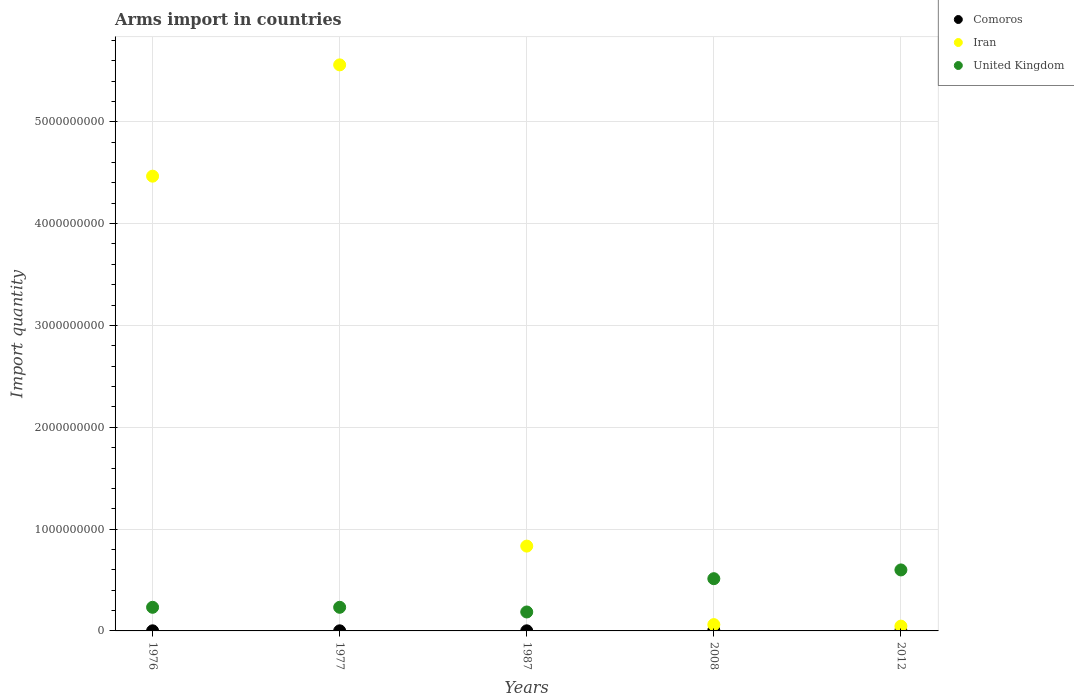Across all years, what is the maximum total arms import in Iran?
Offer a terse response. 5.56e+09. In which year was the total arms import in Comoros minimum?
Provide a short and direct response. 1976. What is the total total arms import in Iran in the graph?
Your response must be concise. 1.10e+1. What is the difference between the total arms import in Comoros in 1976 and that in 2008?
Your response must be concise. -5.00e+06. What is the difference between the total arms import in Iran in 1976 and the total arms import in Comoros in 2008?
Provide a short and direct response. 4.46e+09. What is the average total arms import in United Kingdom per year?
Ensure brevity in your answer.  3.52e+08. In the year 2012, what is the difference between the total arms import in Iran and total arms import in Comoros?
Ensure brevity in your answer.  4.60e+07. What is the difference between the highest and the second highest total arms import in Iran?
Give a very brief answer. 1.09e+09. What is the difference between the highest and the lowest total arms import in Comoros?
Ensure brevity in your answer.  5.00e+06. In how many years, is the total arms import in Iran greater than the average total arms import in Iran taken over all years?
Provide a short and direct response. 2. Is the sum of the total arms import in United Kingdom in 1976 and 1977 greater than the maximum total arms import in Comoros across all years?
Provide a succinct answer. Yes. Is it the case that in every year, the sum of the total arms import in Iran and total arms import in United Kingdom  is greater than the total arms import in Comoros?
Ensure brevity in your answer.  Yes. How many years are there in the graph?
Your response must be concise. 5. What is the difference between two consecutive major ticks on the Y-axis?
Provide a succinct answer. 1.00e+09. Are the values on the major ticks of Y-axis written in scientific E-notation?
Make the answer very short. No. Does the graph contain grids?
Give a very brief answer. Yes. How are the legend labels stacked?
Your response must be concise. Vertical. What is the title of the graph?
Provide a short and direct response. Arms import in countries. What is the label or title of the X-axis?
Your response must be concise. Years. What is the label or title of the Y-axis?
Provide a short and direct response. Import quantity. What is the Import quantity in Comoros in 1976?
Keep it short and to the point. 1.00e+06. What is the Import quantity in Iran in 1976?
Ensure brevity in your answer.  4.47e+09. What is the Import quantity of United Kingdom in 1976?
Your answer should be very brief. 2.32e+08. What is the Import quantity in Comoros in 1977?
Offer a very short reply. 1.00e+06. What is the Import quantity in Iran in 1977?
Give a very brief answer. 5.56e+09. What is the Import quantity in United Kingdom in 1977?
Make the answer very short. 2.32e+08. What is the Import quantity in Comoros in 1987?
Keep it short and to the point. 1.00e+06. What is the Import quantity of Iran in 1987?
Provide a succinct answer. 8.33e+08. What is the Import quantity in United Kingdom in 1987?
Your answer should be compact. 1.86e+08. What is the Import quantity of Iran in 2008?
Give a very brief answer. 6.20e+07. What is the Import quantity in United Kingdom in 2008?
Make the answer very short. 5.13e+08. What is the Import quantity in Iran in 2012?
Ensure brevity in your answer.  4.70e+07. What is the Import quantity of United Kingdom in 2012?
Give a very brief answer. 5.99e+08. Across all years, what is the maximum Import quantity in Iran?
Provide a succinct answer. 5.56e+09. Across all years, what is the maximum Import quantity in United Kingdom?
Your answer should be very brief. 5.99e+08. Across all years, what is the minimum Import quantity of Comoros?
Offer a very short reply. 1.00e+06. Across all years, what is the minimum Import quantity in Iran?
Provide a short and direct response. 4.70e+07. Across all years, what is the minimum Import quantity in United Kingdom?
Your answer should be compact. 1.86e+08. What is the total Import quantity in Comoros in the graph?
Provide a short and direct response. 1.00e+07. What is the total Import quantity of Iran in the graph?
Offer a very short reply. 1.10e+1. What is the total Import quantity of United Kingdom in the graph?
Your response must be concise. 1.76e+09. What is the difference between the Import quantity of Comoros in 1976 and that in 1977?
Make the answer very short. 0. What is the difference between the Import quantity in Iran in 1976 and that in 1977?
Keep it short and to the point. -1.09e+09. What is the difference between the Import quantity in Iran in 1976 and that in 1987?
Offer a very short reply. 3.63e+09. What is the difference between the Import quantity of United Kingdom in 1976 and that in 1987?
Ensure brevity in your answer.  4.60e+07. What is the difference between the Import quantity of Comoros in 1976 and that in 2008?
Ensure brevity in your answer.  -5.00e+06. What is the difference between the Import quantity in Iran in 1976 and that in 2008?
Give a very brief answer. 4.40e+09. What is the difference between the Import quantity of United Kingdom in 1976 and that in 2008?
Provide a short and direct response. -2.81e+08. What is the difference between the Import quantity in Iran in 1976 and that in 2012?
Provide a short and direct response. 4.42e+09. What is the difference between the Import quantity of United Kingdom in 1976 and that in 2012?
Make the answer very short. -3.67e+08. What is the difference between the Import quantity in Comoros in 1977 and that in 1987?
Offer a very short reply. 0. What is the difference between the Import quantity in Iran in 1977 and that in 1987?
Your response must be concise. 4.73e+09. What is the difference between the Import quantity of United Kingdom in 1977 and that in 1987?
Keep it short and to the point. 4.60e+07. What is the difference between the Import quantity of Comoros in 1977 and that in 2008?
Provide a short and direct response. -5.00e+06. What is the difference between the Import quantity in Iran in 1977 and that in 2008?
Offer a terse response. 5.50e+09. What is the difference between the Import quantity of United Kingdom in 1977 and that in 2008?
Offer a very short reply. -2.81e+08. What is the difference between the Import quantity in Comoros in 1977 and that in 2012?
Give a very brief answer. 0. What is the difference between the Import quantity of Iran in 1977 and that in 2012?
Provide a short and direct response. 5.51e+09. What is the difference between the Import quantity in United Kingdom in 1977 and that in 2012?
Ensure brevity in your answer.  -3.67e+08. What is the difference between the Import quantity of Comoros in 1987 and that in 2008?
Provide a short and direct response. -5.00e+06. What is the difference between the Import quantity of Iran in 1987 and that in 2008?
Ensure brevity in your answer.  7.71e+08. What is the difference between the Import quantity in United Kingdom in 1987 and that in 2008?
Offer a very short reply. -3.27e+08. What is the difference between the Import quantity of Iran in 1987 and that in 2012?
Offer a very short reply. 7.86e+08. What is the difference between the Import quantity in United Kingdom in 1987 and that in 2012?
Keep it short and to the point. -4.13e+08. What is the difference between the Import quantity of Comoros in 2008 and that in 2012?
Your response must be concise. 5.00e+06. What is the difference between the Import quantity in Iran in 2008 and that in 2012?
Offer a terse response. 1.50e+07. What is the difference between the Import quantity of United Kingdom in 2008 and that in 2012?
Give a very brief answer. -8.60e+07. What is the difference between the Import quantity in Comoros in 1976 and the Import quantity in Iran in 1977?
Offer a very short reply. -5.56e+09. What is the difference between the Import quantity in Comoros in 1976 and the Import quantity in United Kingdom in 1977?
Your answer should be compact. -2.31e+08. What is the difference between the Import quantity of Iran in 1976 and the Import quantity of United Kingdom in 1977?
Provide a short and direct response. 4.23e+09. What is the difference between the Import quantity of Comoros in 1976 and the Import quantity of Iran in 1987?
Ensure brevity in your answer.  -8.32e+08. What is the difference between the Import quantity of Comoros in 1976 and the Import quantity of United Kingdom in 1987?
Provide a short and direct response. -1.85e+08. What is the difference between the Import quantity of Iran in 1976 and the Import quantity of United Kingdom in 1987?
Ensure brevity in your answer.  4.28e+09. What is the difference between the Import quantity of Comoros in 1976 and the Import quantity of Iran in 2008?
Your answer should be compact. -6.10e+07. What is the difference between the Import quantity in Comoros in 1976 and the Import quantity in United Kingdom in 2008?
Offer a terse response. -5.12e+08. What is the difference between the Import quantity of Iran in 1976 and the Import quantity of United Kingdom in 2008?
Give a very brief answer. 3.95e+09. What is the difference between the Import quantity of Comoros in 1976 and the Import quantity of Iran in 2012?
Your answer should be compact. -4.60e+07. What is the difference between the Import quantity of Comoros in 1976 and the Import quantity of United Kingdom in 2012?
Make the answer very short. -5.98e+08. What is the difference between the Import quantity of Iran in 1976 and the Import quantity of United Kingdom in 2012?
Keep it short and to the point. 3.87e+09. What is the difference between the Import quantity of Comoros in 1977 and the Import quantity of Iran in 1987?
Offer a terse response. -8.32e+08. What is the difference between the Import quantity of Comoros in 1977 and the Import quantity of United Kingdom in 1987?
Provide a short and direct response. -1.85e+08. What is the difference between the Import quantity of Iran in 1977 and the Import quantity of United Kingdom in 1987?
Your response must be concise. 5.37e+09. What is the difference between the Import quantity of Comoros in 1977 and the Import quantity of Iran in 2008?
Provide a short and direct response. -6.10e+07. What is the difference between the Import quantity in Comoros in 1977 and the Import quantity in United Kingdom in 2008?
Give a very brief answer. -5.12e+08. What is the difference between the Import quantity of Iran in 1977 and the Import quantity of United Kingdom in 2008?
Give a very brief answer. 5.05e+09. What is the difference between the Import quantity of Comoros in 1977 and the Import quantity of Iran in 2012?
Your answer should be compact. -4.60e+07. What is the difference between the Import quantity of Comoros in 1977 and the Import quantity of United Kingdom in 2012?
Your answer should be very brief. -5.98e+08. What is the difference between the Import quantity in Iran in 1977 and the Import quantity in United Kingdom in 2012?
Your answer should be compact. 4.96e+09. What is the difference between the Import quantity of Comoros in 1987 and the Import quantity of Iran in 2008?
Provide a short and direct response. -6.10e+07. What is the difference between the Import quantity of Comoros in 1987 and the Import quantity of United Kingdom in 2008?
Give a very brief answer. -5.12e+08. What is the difference between the Import quantity of Iran in 1987 and the Import quantity of United Kingdom in 2008?
Offer a terse response. 3.20e+08. What is the difference between the Import quantity of Comoros in 1987 and the Import quantity of Iran in 2012?
Your response must be concise. -4.60e+07. What is the difference between the Import quantity in Comoros in 1987 and the Import quantity in United Kingdom in 2012?
Offer a terse response. -5.98e+08. What is the difference between the Import quantity of Iran in 1987 and the Import quantity of United Kingdom in 2012?
Your answer should be very brief. 2.34e+08. What is the difference between the Import quantity in Comoros in 2008 and the Import quantity in Iran in 2012?
Keep it short and to the point. -4.10e+07. What is the difference between the Import quantity in Comoros in 2008 and the Import quantity in United Kingdom in 2012?
Your answer should be very brief. -5.93e+08. What is the difference between the Import quantity in Iran in 2008 and the Import quantity in United Kingdom in 2012?
Your answer should be compact. -5.37e+08. What is the average Import quantity of Comoros per year?
Provide a short and direct response. 2.00e+06. What is the average Import quantity in Iran per year?
Your response must be concise. 2.19e+09. What is the average Import quantity in United Kingdom per year?
Provide a succinct answer. 3.52e+08. In the year 1976, what is the difference between the Import quantity in Comoros and Import quantity in Iran?
Provide a succinct answer. -4.46e+09. In the year 1976, what is the difference between the Import quantity in Comoros and Import quantity in United Kingdom?
Provide a succinct answer. -2.31e+08. In the year 1976, what is the difference between the Import quantity of Iran and Import quantity of United Kingdom?
Make the answer very short. 4.23e+09. In the year 1977, what is the difference between the Import quantity in Comoros and Import quantity in Iran?
Keep it short and to the point. -5.56e+09. In the year 1977, what is the difference between the Import quantity in Comoros and Import quantity in United Kingdom?
Make the answer very short. -2.31e+08. In the year 1977, what is the difference between the Import quantity in Iran and Import quantity in United Kingdom?
Give a very brief answer. 5.33e+09. In the year 1987, what is the difference between the Import quantity of Comoros and Import quantity of Iran?
Keep it short and to the point. -8.32e+08. In the year 1987, what is the difference between the Import quantity in Comoros and Import quantity in United Kingdom?
Provide a short and direct response. -1.85e+08. In the year 1987, what is the difference between the Import quantity of Iran and Import quantity of United Kingdom?
Your answer should be very brief. 6.47e+08. In the year 2008, what is the difference between the Import quantity of Comoros and Import quantity of Iran?
Provide a succinct answer. -5.60e+07. In the year 2008, what is the difference between the Import quantity in Comoros and Import quantity in United Kingdom?
Give a very brief answer. -5.07e+08. In the year 2008, what is the difference between the Import quantity in Iran and Import quantity in United Kingdom?
Your answer should be very brief. -4.51e+08. In the year 2012, what is the difference between the Import quantity of Comoros and Import quantity of Iran?
Provide a succinct answer. -4.60e+07. In the year 2012, what is the difference between the Import quantity in Comoros and Import quantity in United Kingdom?
Give a very brief answer. -5.98e+08. In the year 2012, what is the difference between the Import quantity in Iran and Import quantity in United Kingdom?
Your answer should be compact. -5.52e+08. What is the ratio of the Import quantity in Comoros in 1976 to that in 1977?
Provide a short and direct response. 1. What is the ratio of the Import quantity in Iran in 1976 to that in 1977?
Provide a succinct answer. 0.8. What is the ratio of the Import quantity of United Kingdom in 1976 to that in 1977?
Your answer should be very brief. 1. What is the ratio of the Import quantity of Iran in 1976 to that in 1987?
Give a very brief answer. 5.36. What is the ratio of the Import quantity of United Kingdom in 1976 to that in 1987?
Keep it short and to the point. 1.25. What is the ratio of the Import quantity of Iran in 1976 to that in 2008?
Your response must be concise. 72.03. What is the ratio of the Import quantity of United Kingdom in 1976 to that in 2008?
Offer a very short reply. 0.45. What is the ratio of the Import quantity of Iran in 1976 to that in 2012?
Your answer should be compact. 95.02. What is the ratio of the Import quantity in United Kingdom in 1976 to that in 2012?
Provide a succinct answer. 0.39. What is the ratio of the Import quantity of Iran in 1977 to that in 1987?
Ensure brevity in your answer.  6.67. What is the ratio of the Import quantity in United Kingdom in 1977 to that in 1987?
Your answer should be very brief. 1.25. What is the ratio of the Import quantity of Iran in 1977 to that in 2008?
Your response must be concise. 89.66. What is the ratio of the Import quantity of United Kingdom in 1977 to that in 2008?
Give a very brief answer. 0.45. What is the ratio of the Import quantity of Iran in 1977 to that in 2012?
Make the answer very short. 118.28. What is the ratio of the Import quantity in United Kingdom in 1977 to that in 2012?
Keep it short and to the point. 0.39. What is the ratio of the Import quantity of Comoros in 1987 to that in 2008?
Your answer should be compact. 0.17. What is the ratio of the Import quantity of Iran in 1987 to that in 2008?
Offer a very short reply. 13.44. What is the ratio of the Import quantity of United Kingdom in 1987 to that in 2008?
Your answer should be very brief. 0.36. What is the ratio of the Import quantity in Comoros in 1987 to that in 2012?
Keep it short and to the point. 1. What is the ratio of the Import quantity in Iran in 1987 to that in 2012?
Offer a terse response. 17.72. What is the ratio of the Import quantity in United Kingdom in 1987 to that in 2012?
Give a very brief answer. 0.31. What is the ratio of the Import quantity of Iran in 2008 to that in 2012?
Your answer should be compact. 1.32. What is the ratio of the Import quantity of United Kingdom in 2008 to that in 2012?
Your answer should be very brief. 0.86. What is the difference between the highest and the second highest Import quantity in Comoros?
Provide a succinct answer. 5.00e+06. What is the difference between the highest and the second highest Import quantity of Iran?
Your answer should be very brief. 1.09e+09. What is the difference between the highest and the second highest Import quantity of United Kingdom?
Keep it short and to the point. 8.60e+07. What is the difference between the highest and the lowest Import quantity of Comoros?
Ensure brevity in your answer.  5.00e+06. What is the difference between the highest and the lowest Import quantity in Iran?
Your response must be concise. 5.51e+09. What is the difference between the highest and the lowest Import quantity of United Kingdom?
Your answer should be very brief. 4.13e+08. 